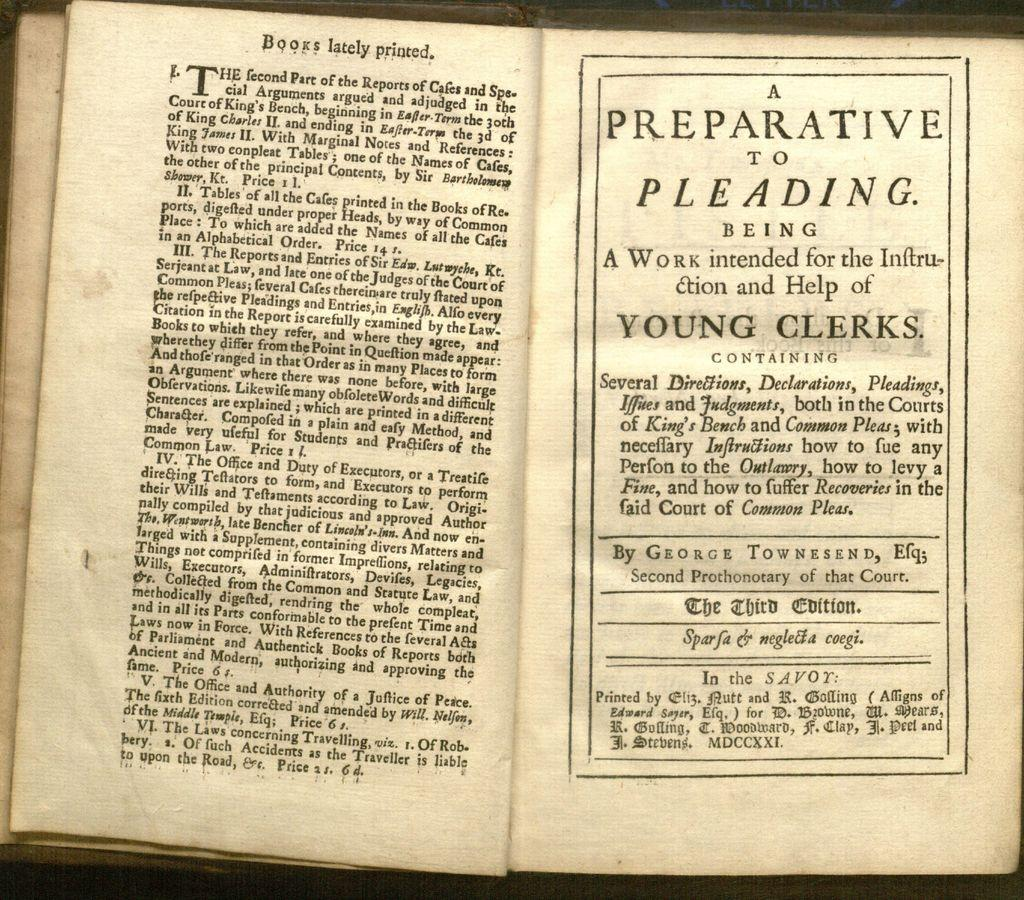Provide a one-sentence caption for the provided image. a few open pages of an old book entitled A PREPARATIVE TO PLEADING By GEORGE TOWNSEND. 